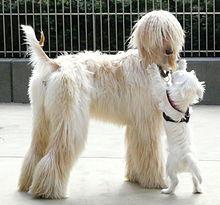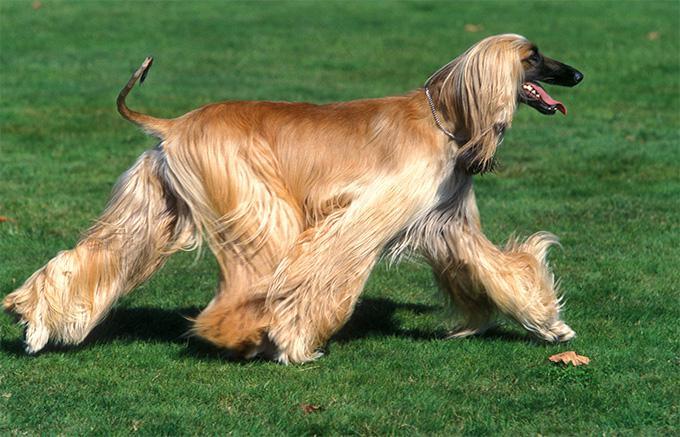The first image is the image on the left, the second image is the image on the right. For the images displayed, is the sentence "There is at least one dog standing on all fours in the image on the left." factually correct? Answer yes or no. Yes. The first image is the image on the left, the second image is the image on the right. Assess this claim about the two images: "the dog on the right image is facing left.". Correct or not? Answer yes or no. No. The first image is the image on the left, the second image is the image on the right. Evaluate the accuracy of this statement regarding the images: "An image shows a standing dog with a leash attached.". Is it true? Answer yes or no. No. 